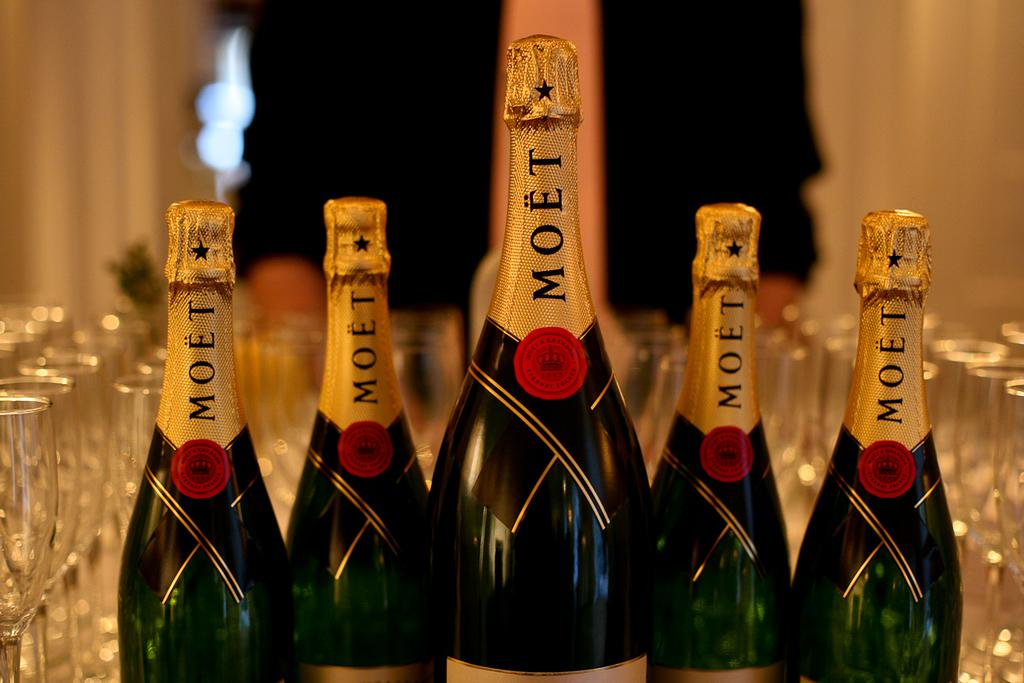Provide a one-sentence caption for the provided image. Bottles of wine sit in a table with each other and MOET is written on it. 